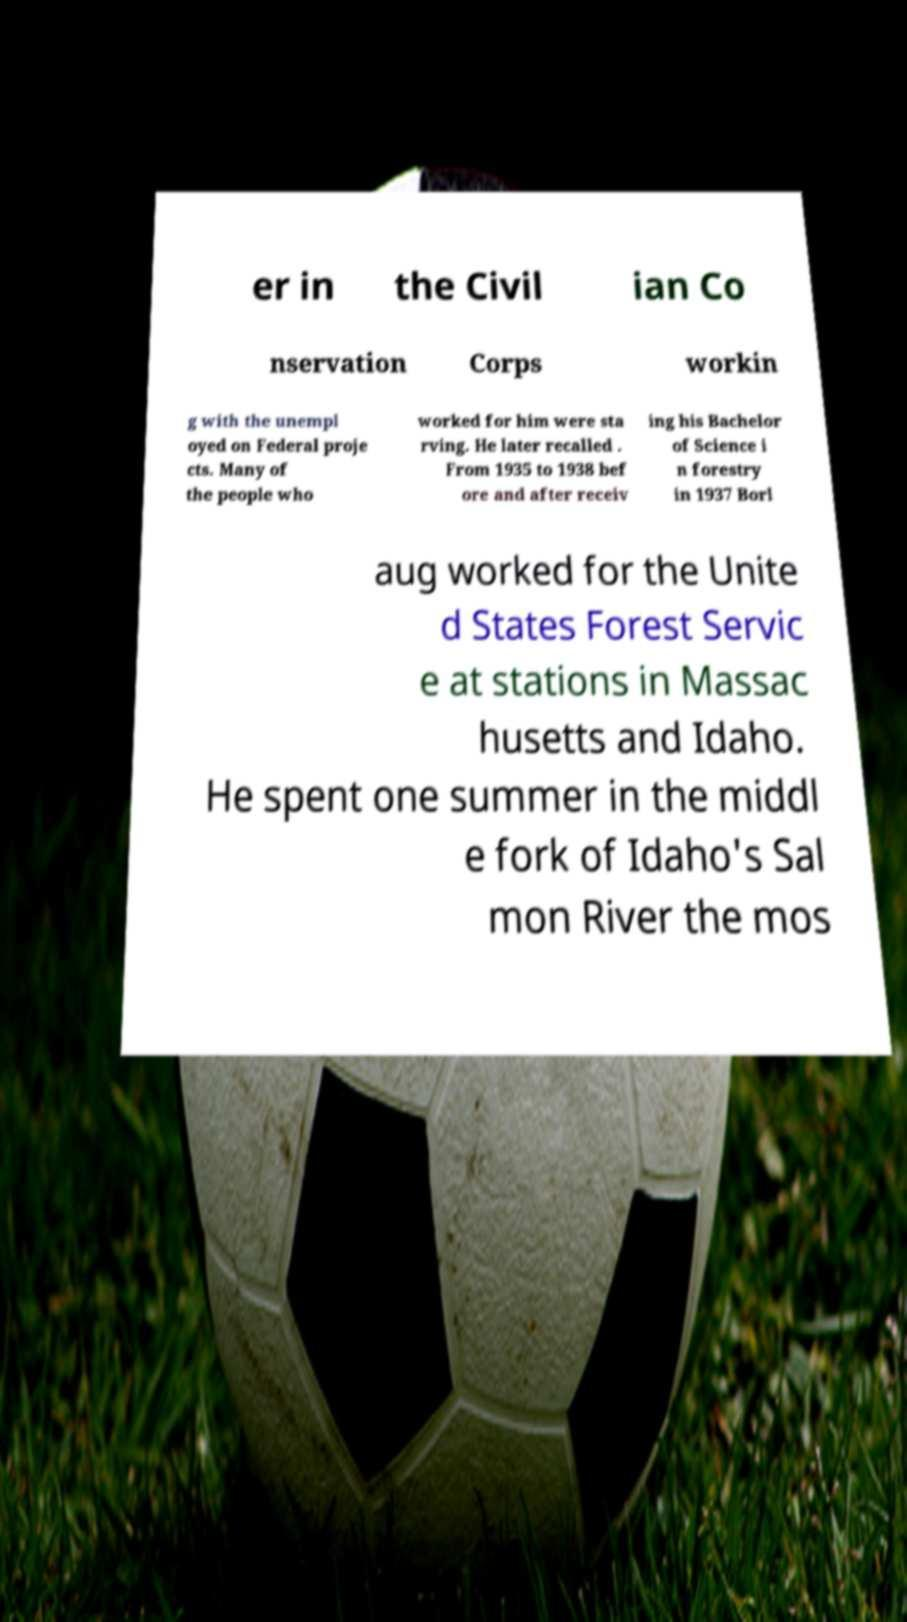What messages or text are displayed in this image? I need them in a readable, typed format. er in the Civil ian Co nservation Corps workin g with the unempl oyed on Federal proje cts. Many of the people who worked for him were sta rving. He later recalled . From 1935 to 1938 bef ore and after receiv ing his Bachelor of Science i n forestry in 1937 Borl aug worked for the Unite d States Forest Servic e at stations in Massac husetts and Idaho. He spent one summer in the middl e fork of Idaho's Sal mon River the mos 